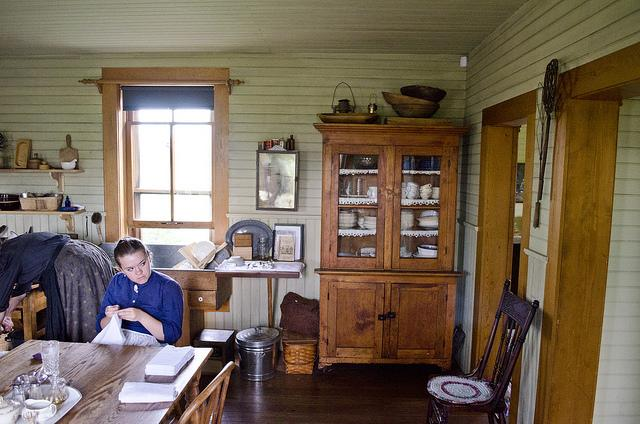What is this woman doing? sewing 